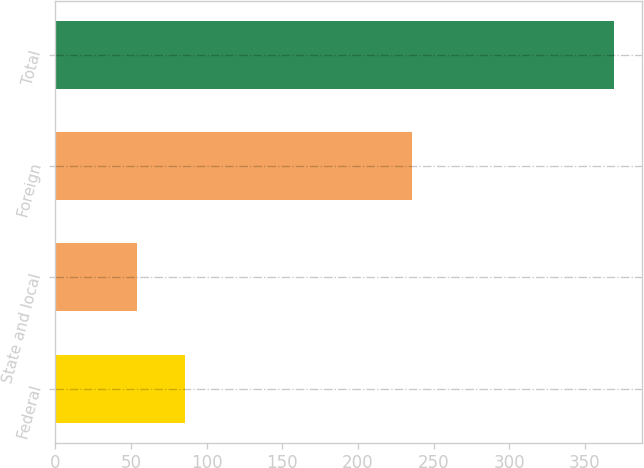Convert chart. <chart><loc_0><loc_0><loc_500><loc_500><bar_chart><fcel>Federal<fcel>State and local<fcel>Foreign<fcel>Total<nl><fcel>85.5<fcel>54<fcel>236<fcel>369<nl></chart> 